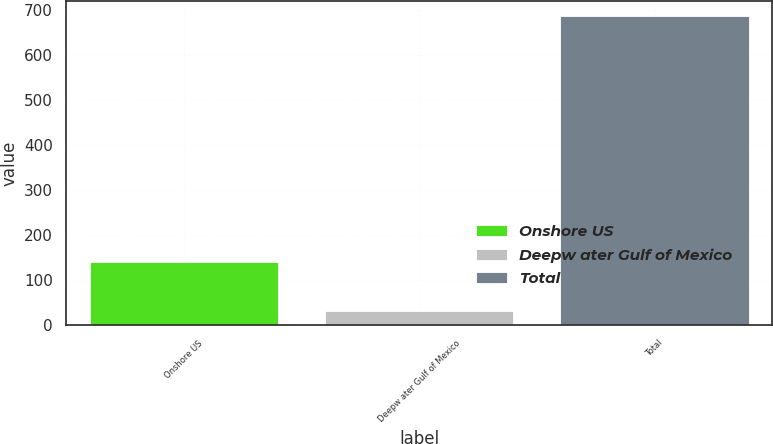Convert chart to OTSL. <chart><loc_0><loc_0><loc_500><loc_500><bar_chart><fcel>Onshore US<fcel>Deepw ater Gulf of Mexico<fcel>Total<nl><fcel>140<fcel>31<fcel>685<nl></chart> 